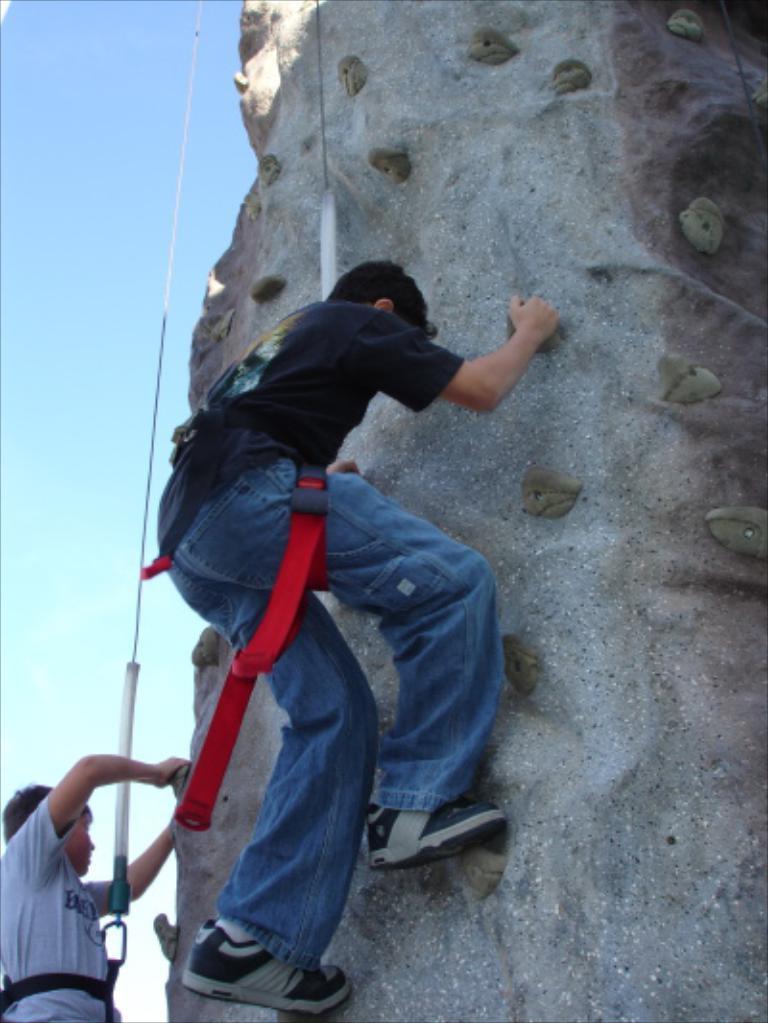In one or two sentences, can you explain what this image depicts? In the foreground, I can see two persons are climbing on a rock. In the background, I can see ropes and the sky. This image is taken, maybe during a day. 